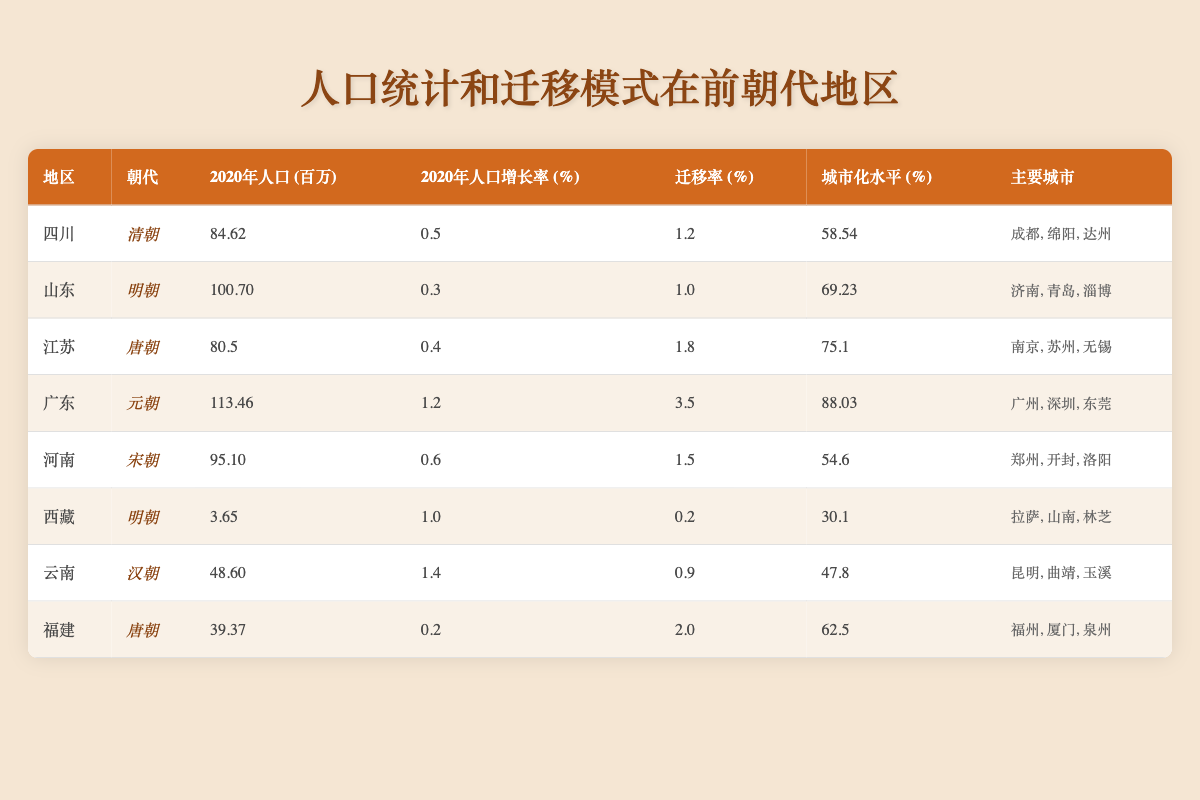What is the population of Guangdong in 2020? Referring to the table, the value listed under "2020年人口 (百万)" for the region Guangdong is 113.46.
Answer: 113.46 million Which region has the highest urbanization level? By comparing the "城市化水平 (%)" values in the table, Guangdong has the highest urbanization level at 88.03%.
Answer: Guangdong What is the migration rate for Jiangsu? The migration rate for Jiangsu is found directly in the table under "迁移率 (%)", which shows a value of 1.8.
Answer: 1.8% Which dynasty corresponds to the region with the lowest population in 2020? The region with the lowest population in 2020 is Tibet with a population of 3.65 million, which corresponds to the Ming dynasty.
Answer: Ming dynasty Calculate the difference in population between Shandong and Henan in 2020. The population of Shandong is 100.70 million, and the population of Henan is 95.10 million. The difference is calculated as 100.70 - 95.10 = 5.60 million.
Answer: 5.60 million What percentage of the regions listed have a population growth rate greater than 1%? There are 8 regions in total. Among them, Guangdong and Yunnan have growth rates above 1%. So, 2 out of 8 regions give a percentage of (2/8)*100 = 25%.
Answer: 25% Is the urbanization level of Tibet higher than that of Yunnan? Checking the "城市化水平 (%)" in the table, Tibet has an urbanization level of 30.1%, while Yunnan has 47.8%. Therefore, Tibet's level is not higher than Yunnan's.
Answer: No Combine the migration rates of Qing and Ming dynasties to find the total migration rate. The migration rate for Qing (Sichuan) is 1.2% and for Ming (Shandong) is 1.0%. Summing these, we get 1.2 + 1.0 = 2.2%.
Answer: 2.2% Which region has the lowest population growth rate, and what is that rate? From the table, we can see that Shandong has the lowest population growth rate at 0.3%.
Answer: 0.3% Which region has more major cities, Sichuan or Fujian? Sichuan has three major cities listed (Chengdu, Mianyang, Dazhou), while Fujian also has three major cities (Fuzhou, Xiamen, Quanzhou). Therefore, they have the same number of major cities.
Answer: They have the same number of major cities 